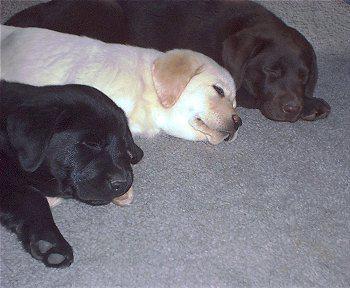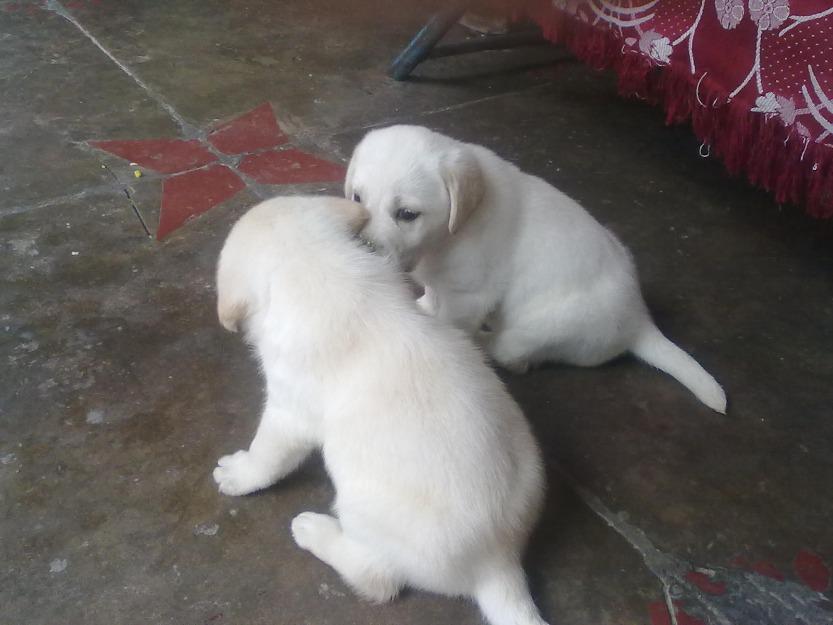The first image is the image on the left, the second image is the image on the right. Considering the images on both sides, is "There are five puppies in the image pair." valid? Answer yes or no. Yes. The first image is the image on the left, the second image is the image on the right. For the images displayed, is the sentence "There are no more than two dogs in the right image." factually correct? Answer yes or no. Yes. 